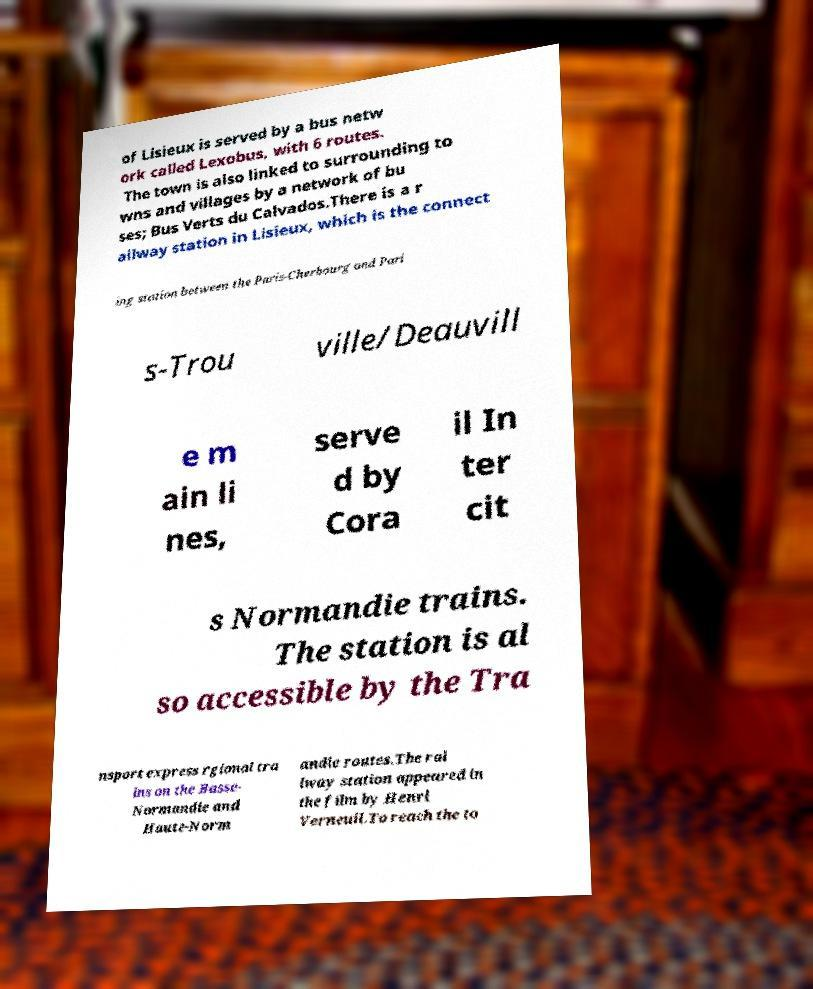Please identify and transcribe the text found in this image. of Lisieux is served by a bus netw ork called Lexobus, with 6 routes. The town is also linked to surrounding to wns and villages by a network of bu ses; Bus Verts du Calvados.There is a r ailway station in Lisieux, which is the connect ing station between the Paris-Cherbourg and Pari s-Trou ville/Deauvill e m ain li nes, serve d by Cora il In ter cit s Normandie trains. The station is al so accessible by the Tra nsport express rgional tra ins on the Basse- Normandie and Haute-Norm andie routes.The rai lway station appeared in the film by Henri Verneuil.To reach the to 